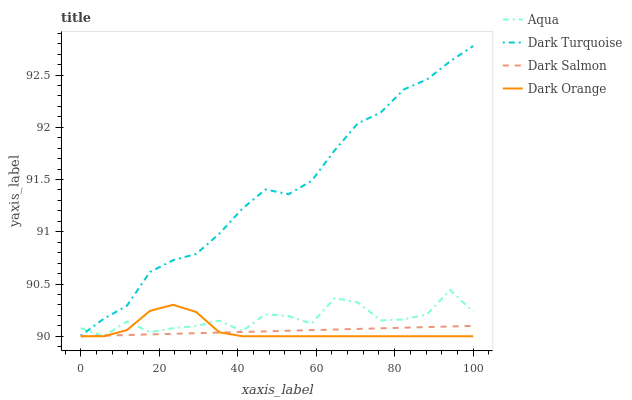Does Dark Salmon have the minimum area under the curve?
Answer yes or no. Yes. Does Dark Turquoise have the maximum area under the curve?
Answer yes or no. Yes. Does Aqua have the minimum area under the curve?
Answer yes or no. No. Does Aqua have the maximum area under the curve?
Answer yes or no. No. Is Dark Salmon the smoothest?
Answer yes or no. Yes. Is Aqua the roughest?
Answer yes or no. Yes. Is Aqua the smoothest?
Answer yes or no. No. Is Dark Salmon the roughest?
Answer yes or no. No. Does Aqua have the lowest value?
Answer yes or no. Yes. Does Dark Turquoise have the highest value?
Answer yes or no. Yes. Does Aqua have the highest value?
Answer yes or no. No. Is Dark Orange less than Dark Turquoise?
Answer yes or no. Yes. Is Dark Turquoise greater than Dark Orange?
Answer yes or no. Yes. Does Aqua intersect Dark Turquoise?
Answer yes or no. Yes. Is Aqua less than Dark Turquoise?
Answer yes or no. No. Is Aqua greater than Dark Turquoise?
Answer yes or no. No. Does Dark Orange intersect Dark Turquoise?
Answer yes or no. No. 